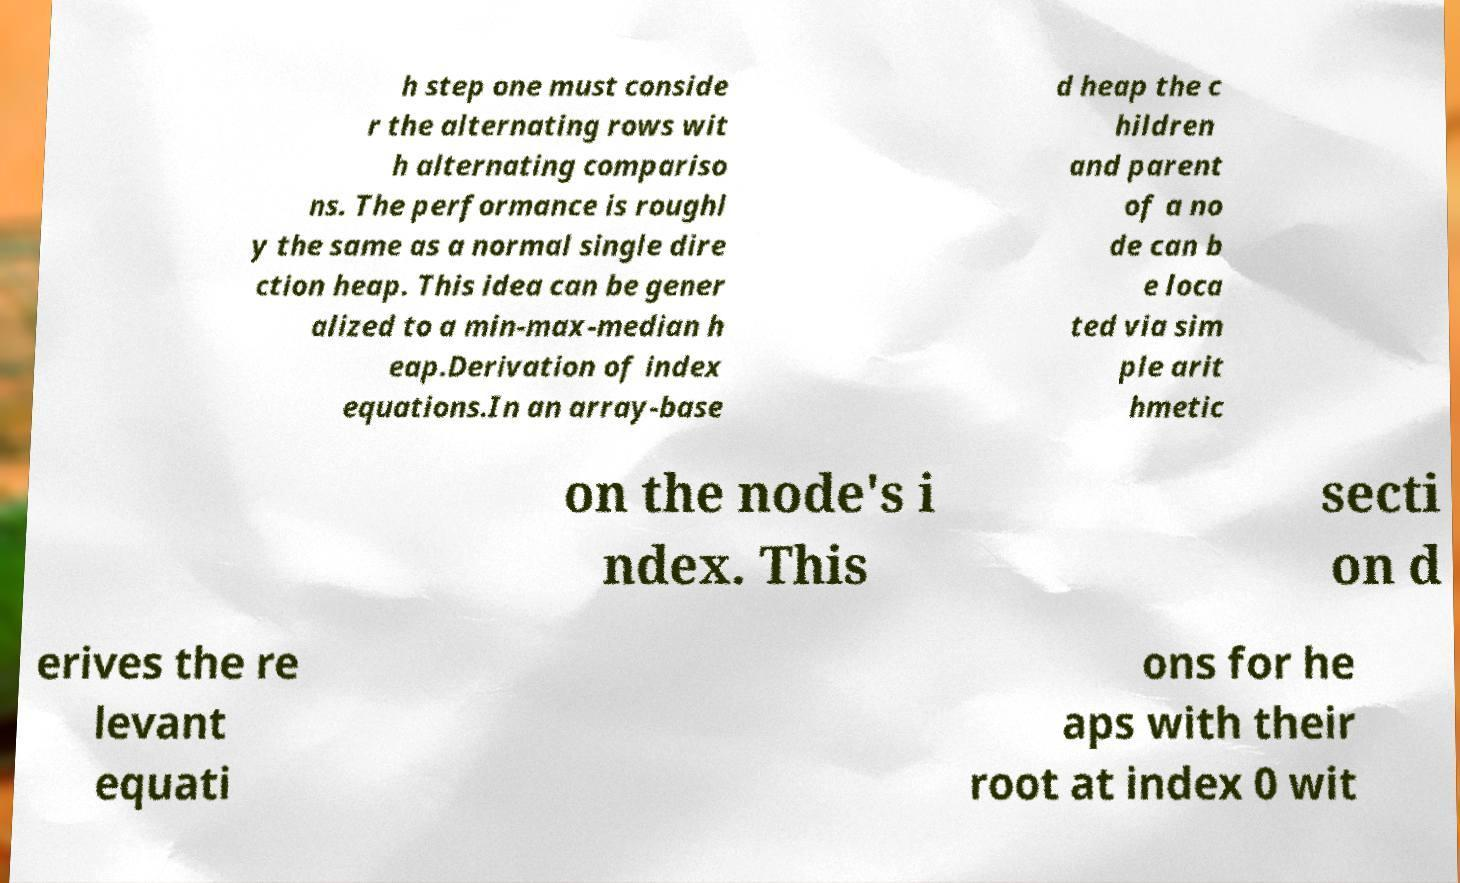Please read and relay the text visible in this image. What does it say? h step one must conside r the alternating rows wit h alternating compariso ns. The performance is roughl y the same as a normal single dire ction heap. This idea can be gener alized to a min-max-median h eap.Derivation of index equations.In an array-base d heap the c hildren and parent of a no de can b e loca ted via sim ple arit hmetic on the node's i ndex. This secti on d erives the re levant equati ons for he aps with their root at index 0 wit 